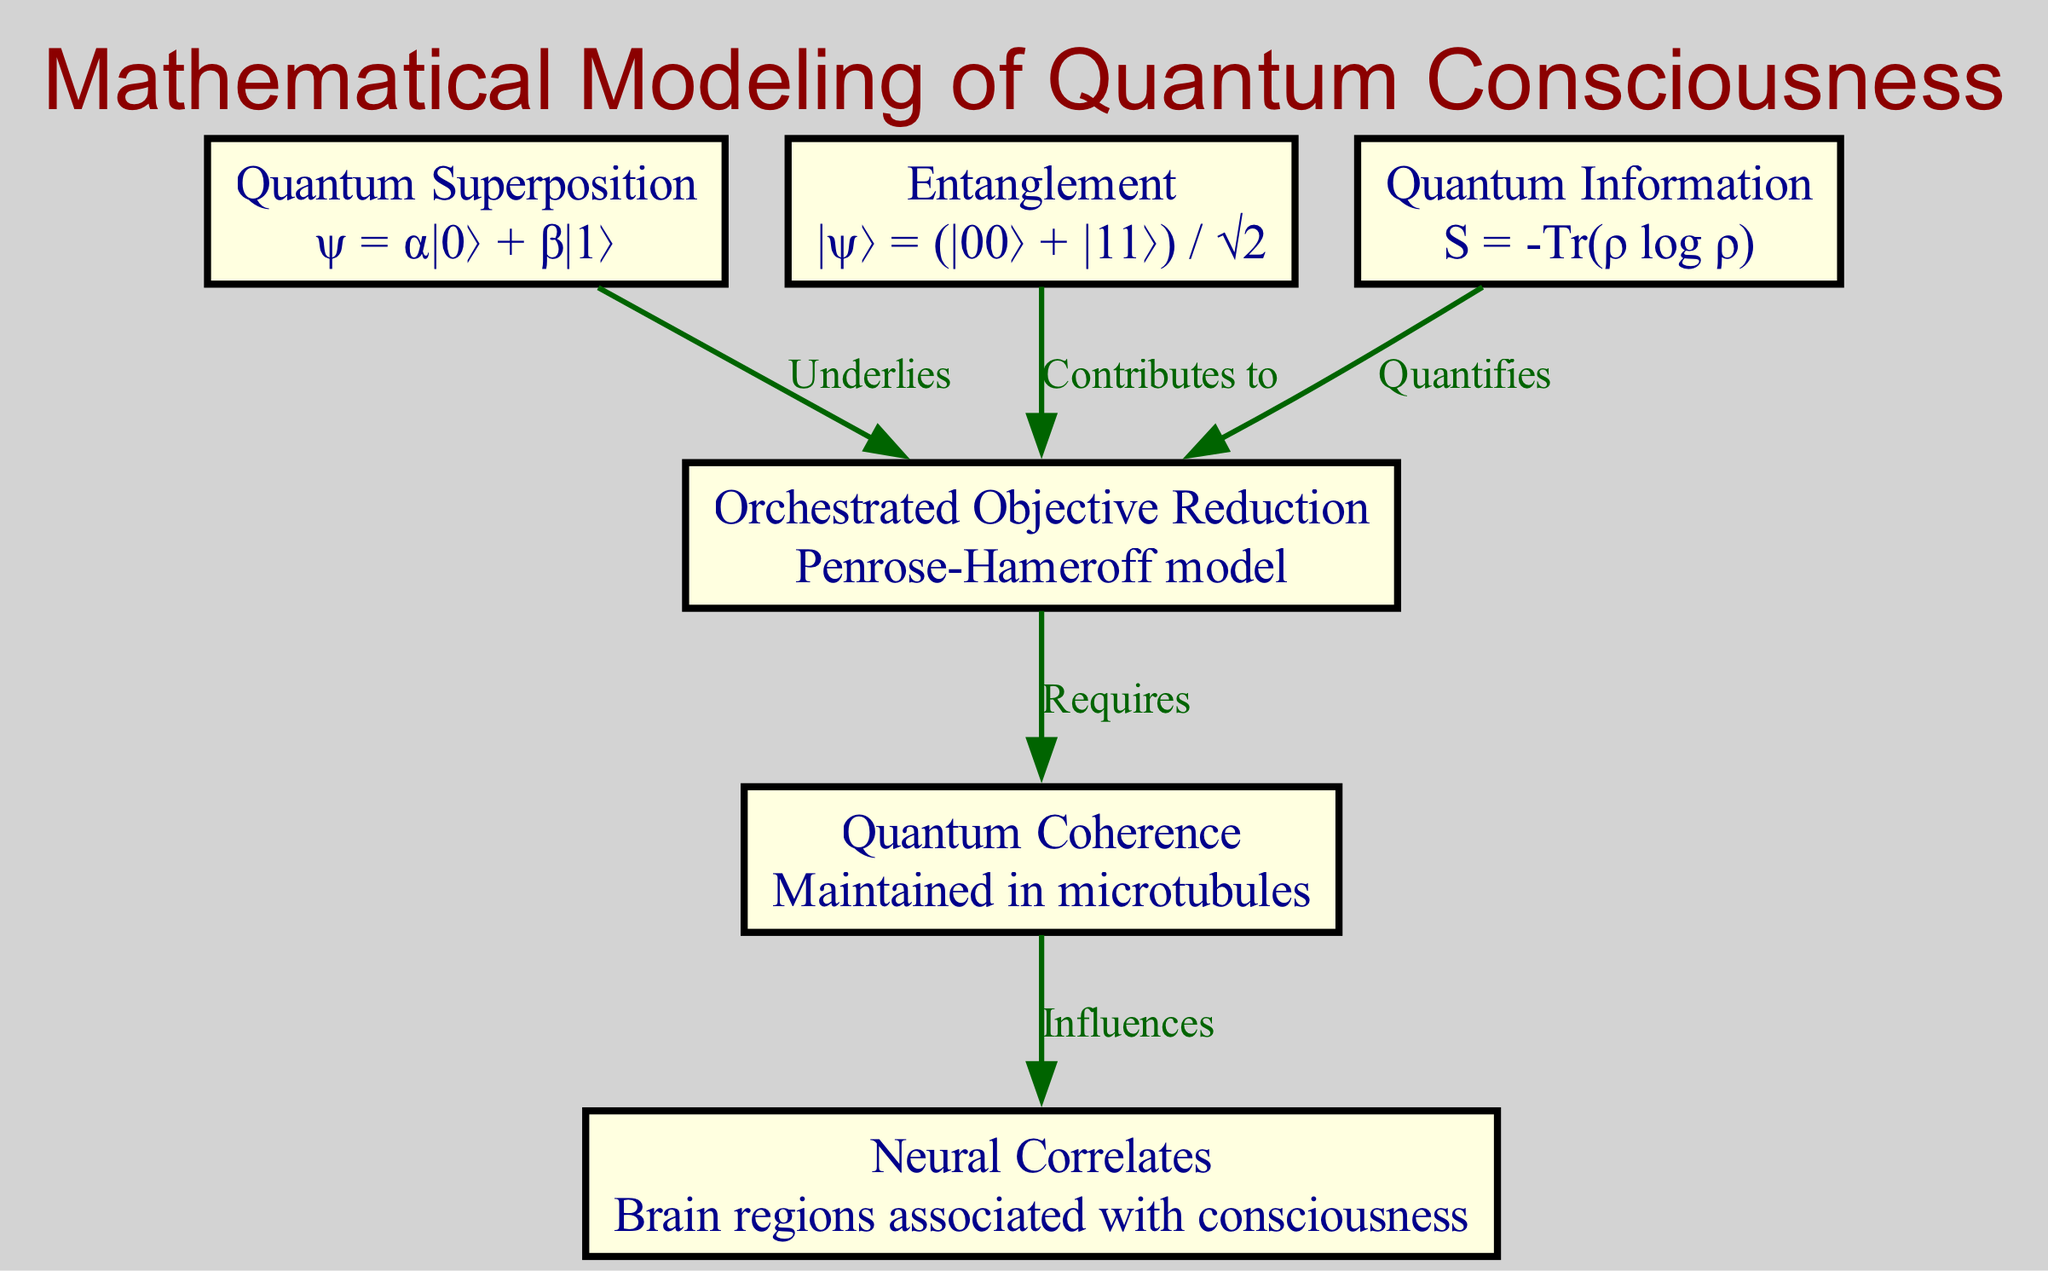How many nodes are in the diagram? By examining the nodes section of the diagram, there are a total of six distinct nodes represented.
Answer: 6 What relationship exists between Quantum Superposition and Orchestrated Objective Reduction? The diagram shows an edge labeled "Underlies" connecting Quantum Superposition (Node 1) to Orchestrated Objective Reduction (Node 3). This indicates a one-way relationship where one concept underlies the other.
Answer: Underlies Which concept influences Neural Correlates? The diagram indicates that Quantum Coherence (Node 4) has a direct influence on Neural Correlates (Node 5), as shown by the labeled edge "Influences".
Answer: Influences What is used to quantify Orchestrated Objective Reduction? Quantum Information (Node 6) quantifies Orchestrated Objective Reduction (Node 3), as depicted by the edge labeled "Quantifies" that connects these two nodes.
Answer: Quantifies How does Quantum Coherence relate to Orchestrated Objective Reduction? Quantum Coherence (Node 4) is indicated to be a requirement for Orchestrated Objective Reduction (Node 3), as represented by the labeled edge that states "Requires".
Answer: Requires Which two concepts are connected by the relationship labeled "Contributes to"? The diagram indicates that Entanglement (Node 2) contributes to Orchestrated Objective Reduction (Node 3), connecting them through the edge labeled "Contributes to".
Answer: Contributes to 